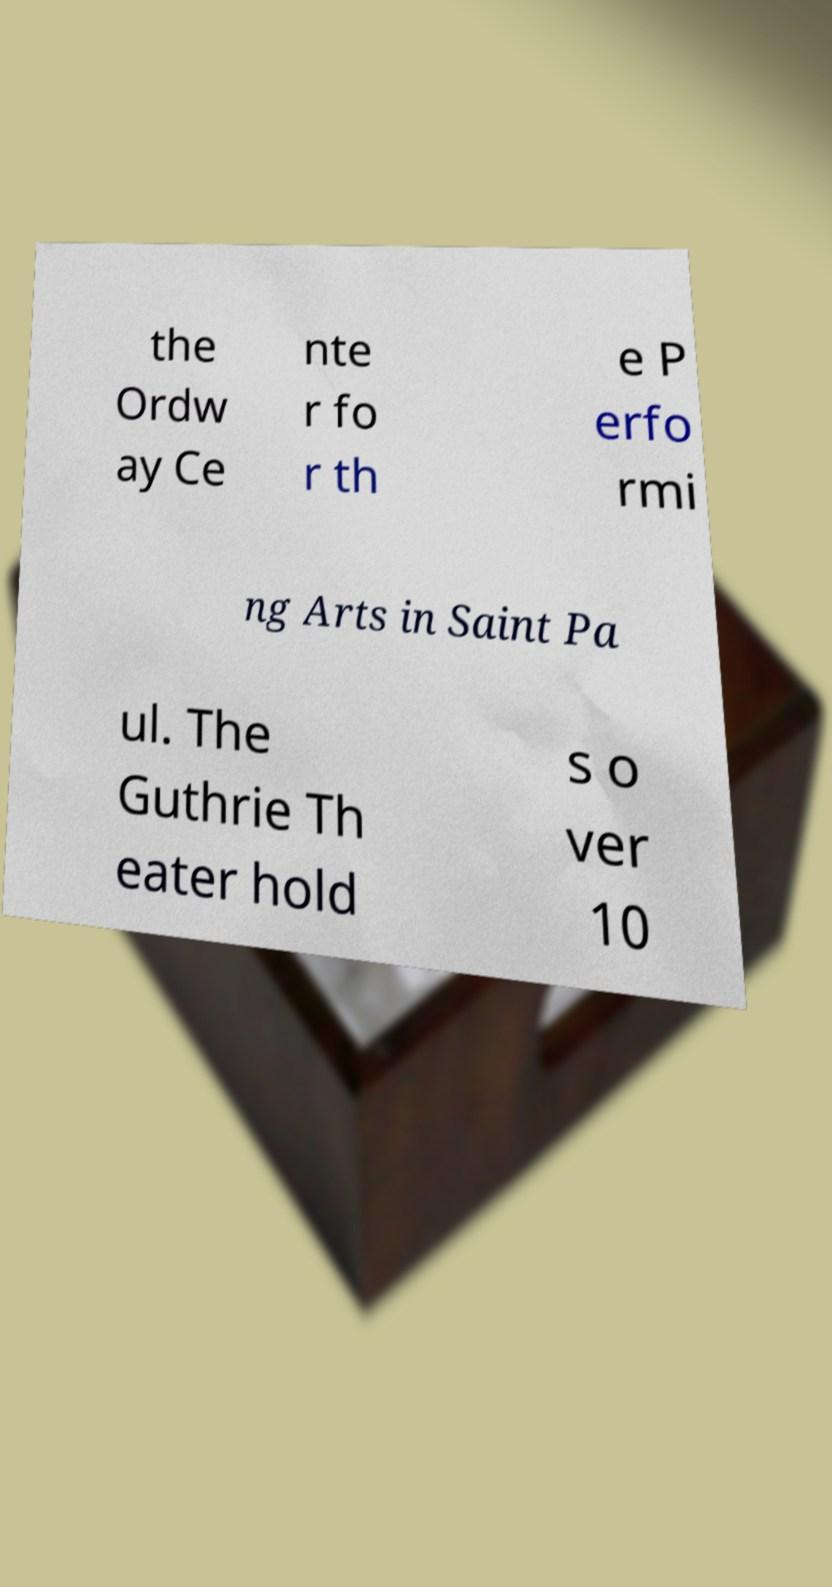Please identify and transcribe the text found in this image. the Ordw ay Ce nte r fo r th e P erfo rmi ng Arts in Saint Pa ul. The Guthrie Th eater hold s o ver 10 